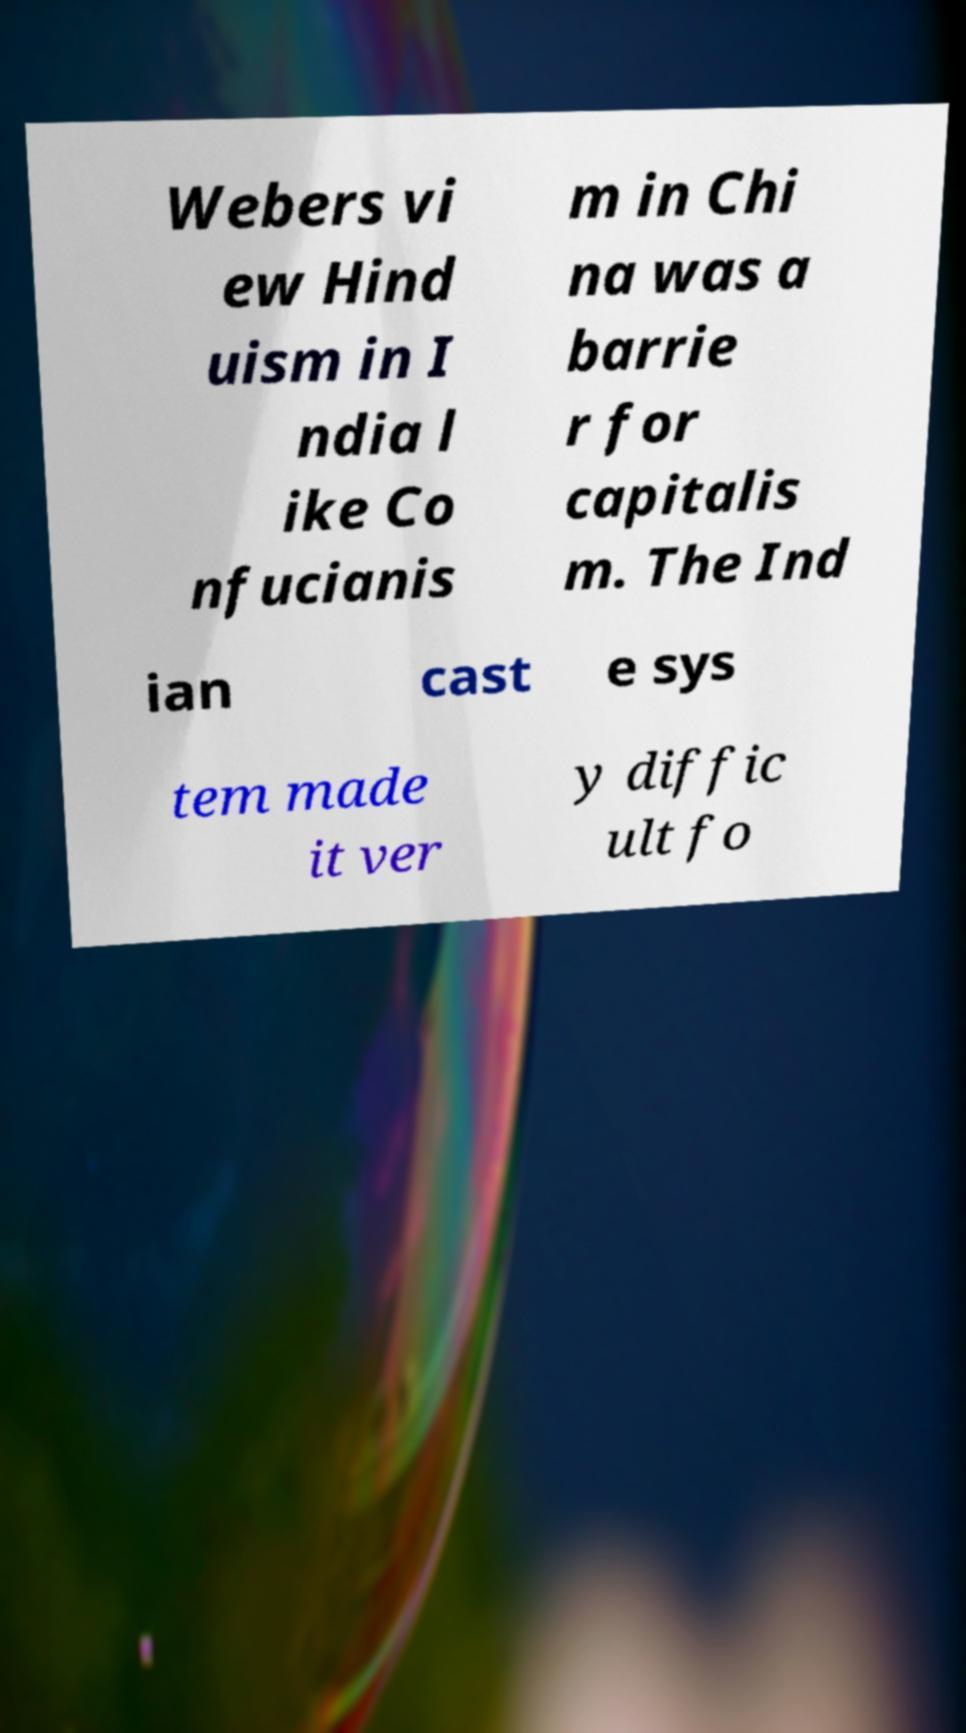For documentation purposes, I need the text within this image transcribed. Could you provide that? Webers vi ew Hind uism in I ndia l ike Co nfucianis m in Chi na was a barrie r for capitalis m. The Ind ian cast e sys tem made it ver y diffic ult fo 